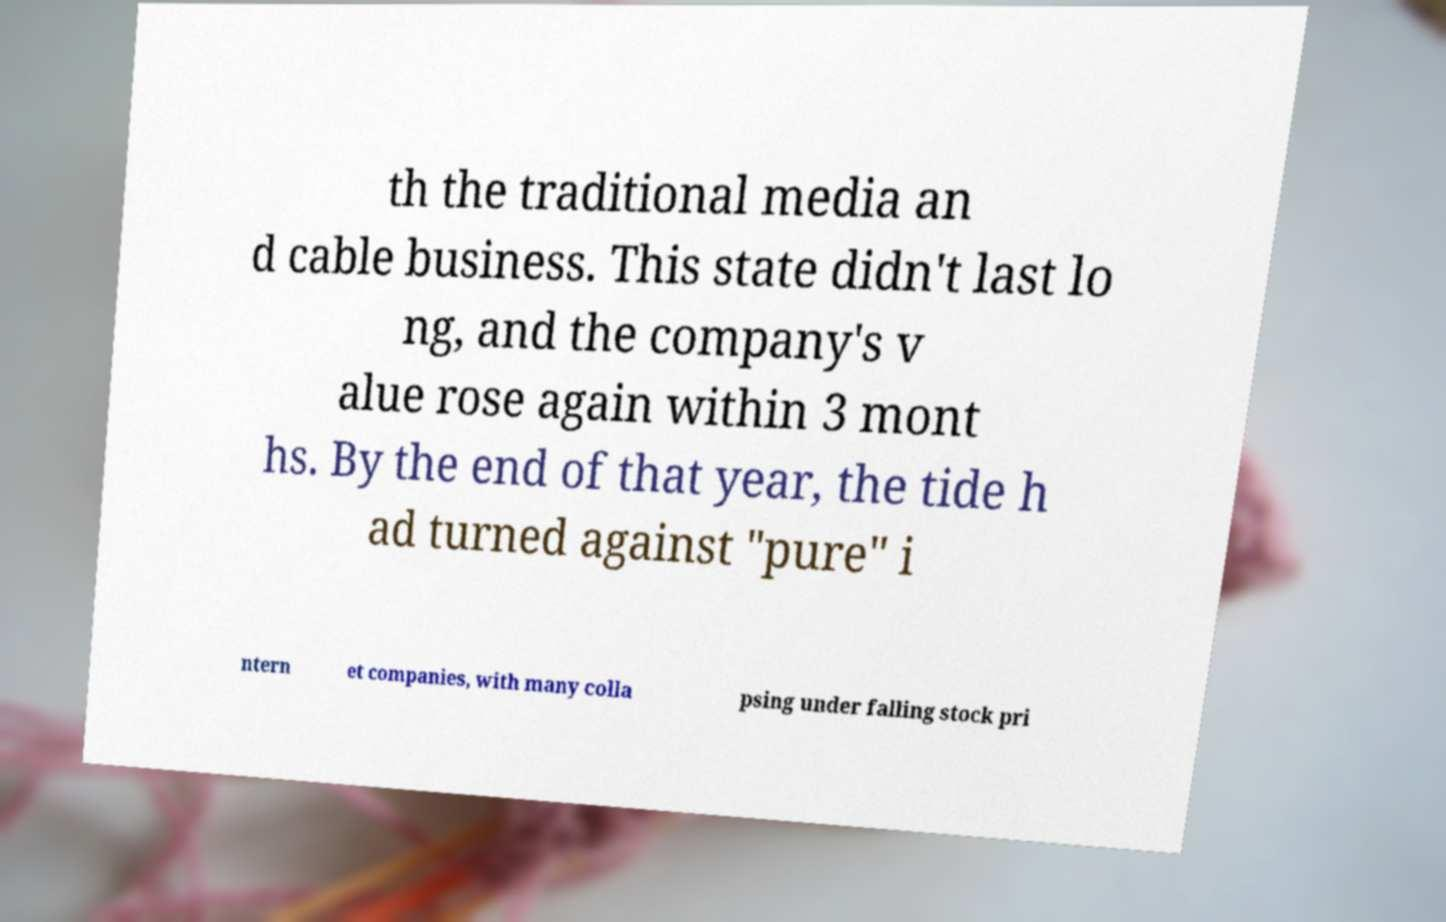Please identify and transcribe the text found in this image. th the traditional media an d cable business. This state didn't last lo ng, and the company's v alue rose again within 3 mont hs. By the end of that year, the tide h ad turned against "pure" i ntern et companies, with many colla psing under falling stock pri 